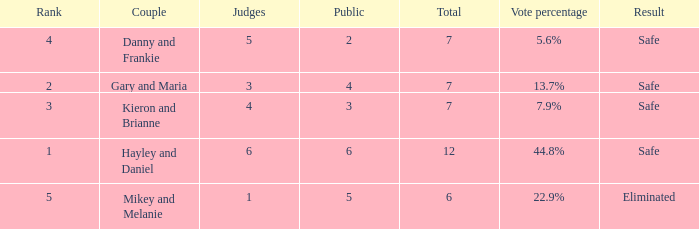What was the maximum rank for the vote percentage of 5.6% 4.0. 